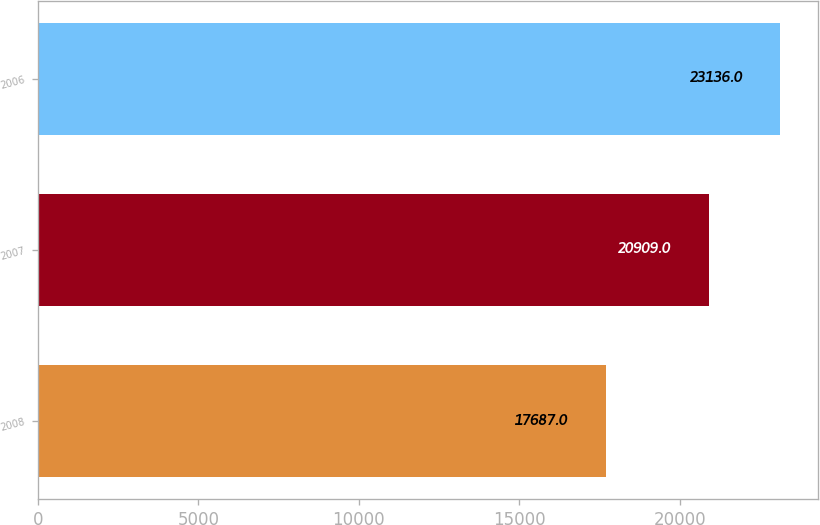<chart> <loc_0><loc_0><loc_500><loc_500><bar_chart><fcel>2008<fcel>2007<fcel>2006<nl><fcel>17687<fcel>20909<fcel>23136<nl></chart> 